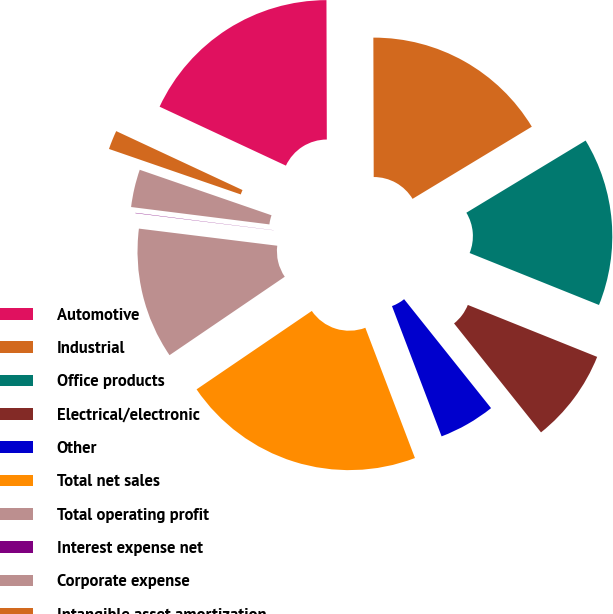Convert chart. <chart><loc_0><loc_0><loc_500><loc_500><pie_chart><fcel>Automotive<fcel>Industrial<fcel>Office products<fcel>Electrical/electronic<fcel>Other<fcel>Total net sales<fcel>Total operating profit<fcel>Interest expense net<fcel>Corporate expense<fcel>Intangible asset amortization<nl><fcel>18.01%<fcel>16.38%<fcel>14.74%<fcel>8.2%<fcel>4.93%<fcel>21.28%<fcel>11.47%<fcel>0.03%<fcel>3.3%<fcel>1.66%<nl></chart> 